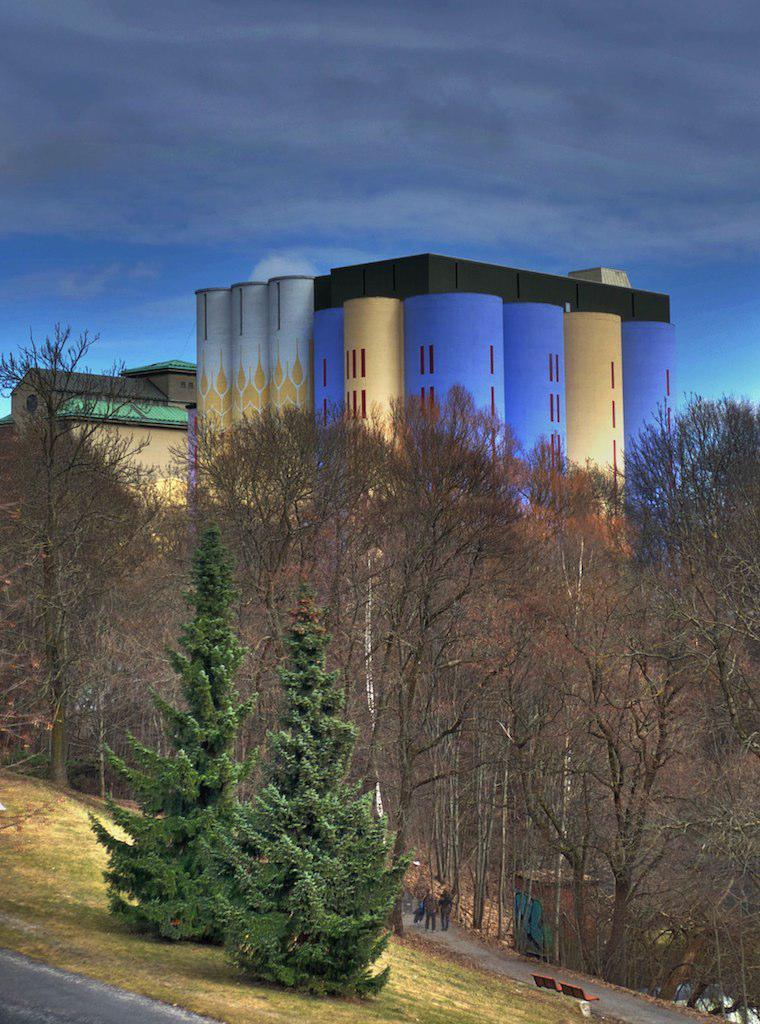What types of plants can be seen in the foreground of the image? There are two plants in the foreground of the image. What can be seen in the middle of the image? There is a road in the image, and people are visible on the road. What type of seating is present in the image? There is a bench in the image. What other natural elements are present in the image? Trees are present in the image. What type of man-made structures can be seen in the image? Buildings are visible in the image. What is visible at the top of the image? The sky is visible at the top of the image. How many ducks are following the cart in the image? There is no cart or ducks present in the image. What route are the people taking in the image? The image does not provide information about the route the people are taking. 